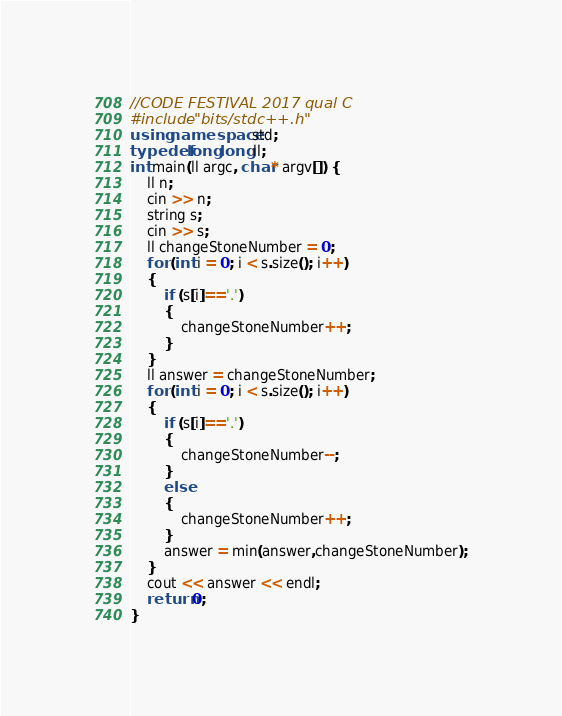Convert code to text. <code><loc_0><loc_0><loc_500><loc_500><_C++_>//CODE FESTIVAL 2017 qual C
#include "bits/stdc++.h"
using namespace std;
typedef long long ll;
int main(ll argc, char* argv[]) {
	ll n;
	cin >> n;
	string s;
	cin >> s;
	ll changeStoneNumber = 0;
	for (int i = 0; i < s.size(); i++)
	{
		if (s[i]=='.')
		{
			changeStoneNumber++;
		}
	}
	ll answer = changeStoneNumber;
	for (int i = 0; i < s.size(); i++)
	{
		if (s[i]=='.')
		{
			changeStoneNumber--;
		}
		else
		{
			changeStoneNumber++;
		}
		answer = min(answer,changeStoneNumber);
	}
	cout << answer << endl;
	return 0;
}</code> 